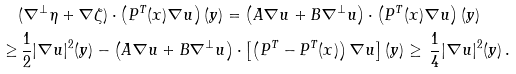Convert formula to latex. <formula><loc_0><loc_0><loc_500><loc_500>& ( \nabla ^ { \perp } \eta + \nabla \zeta ) \cdot \left ( P ^ { T } ( x ) \nabla u \right ) ( y ) = \left ( A \nabla u + B \nabla ^ { \perp } u \right ) \cdot \left ( P ^ { T } ( x ) \nabla u \right ) ( y ) \\ \geq & \, \frac { 1 } { 2 } | \nabla u | ^ { 2 } ( y ) - \left ( A \nabla u + B \nabla ^ { \perp } u \right ) \cdot \left [ \left ( P ^ { T } - P ^ { T } ( x ) \right ) \nabla u \right ] ( y ) \geq \, \frac { 1 } { 4 } | \nabla u | ^ { 2 } ( y ) \, .</formula> 